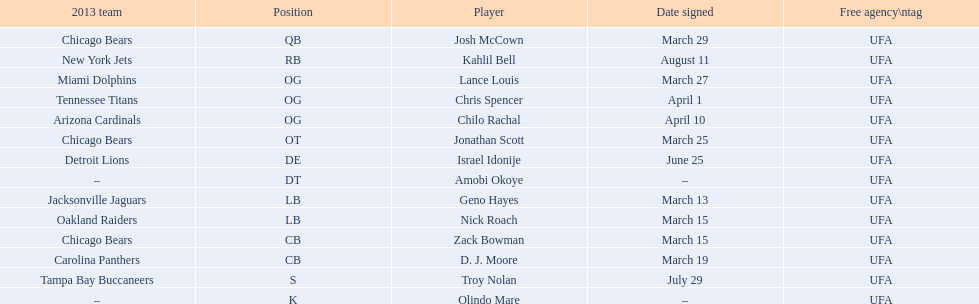Who are all the players on the 2013 chicago bears season team? Josh McCown, Kahlil Bell, Lance Louis, Chris Spencer, Chilo Rachal, Jonathan Scott, Israel Idonije, Amobi Okoye, Geno Hayes, Nick Roach, Zack Bowman, D. J. Moore, Troy Nolan, Olindo Mare. What day was nick roach signed? March 15. What other day matches this? March 15. Who was signed on the day? Zack Bowman. 